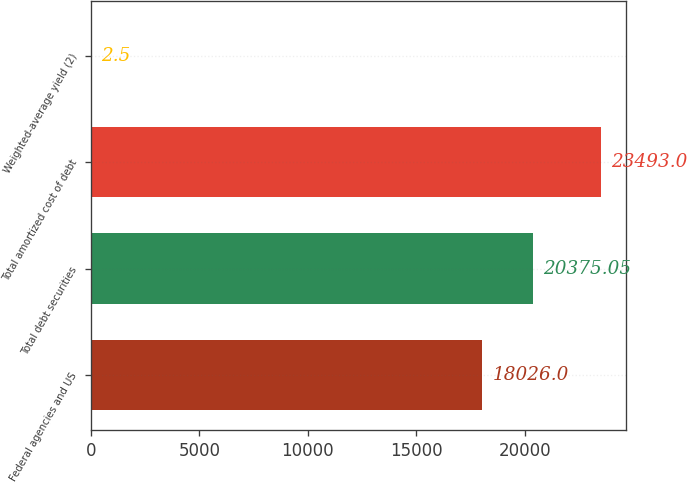Convert chart to OTSL. <chart><loc_0><loc_0><loc_500><loc_500><bar_chart><fcel>Federal agencies and US<fcel>Total debt securities<fcel>Total amortized cost of debt<fcel>Weighted-average yield (2)<nl><fcel>18026<fcel>20375<fcel>23493<fcel>2.5<nl></chart> 